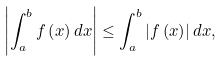Convert formula to latex. <formula><loc_0><loc_0><loc_500><loc_500>\left | \int _ { a } ^ { b } f \left ( x \right ) d x \right | \leq \int _ { a } ^ { b } \left | f \left ( x \right ) \right | d x ,</formula> 